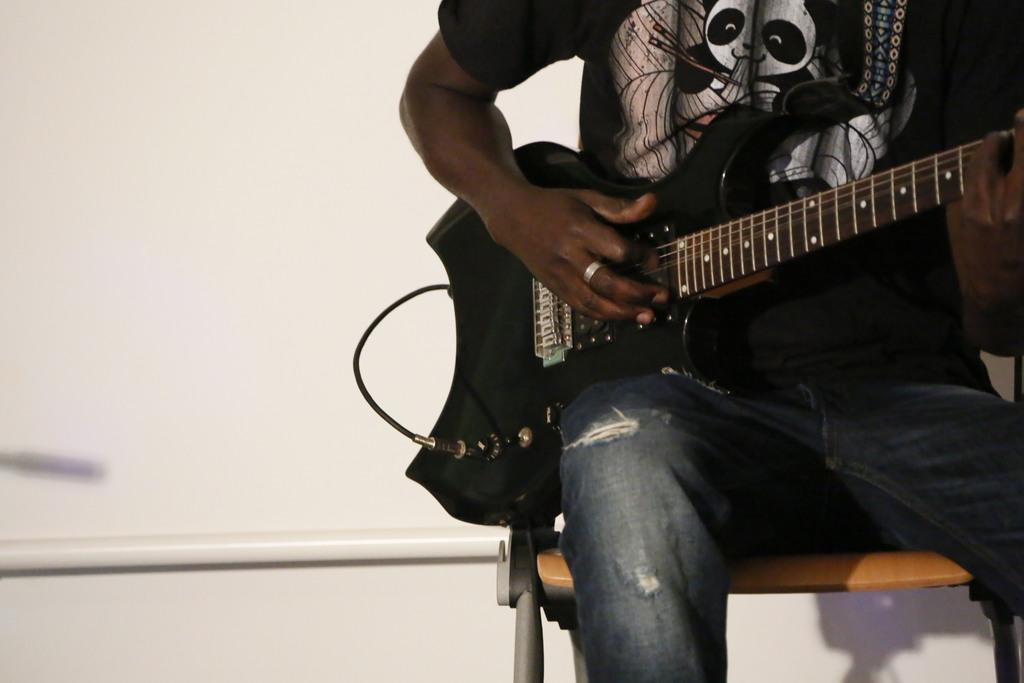Can you describe this image briefly? In this picture there is a person sitting on the chair and holding guitar. On the background we can see wall. 